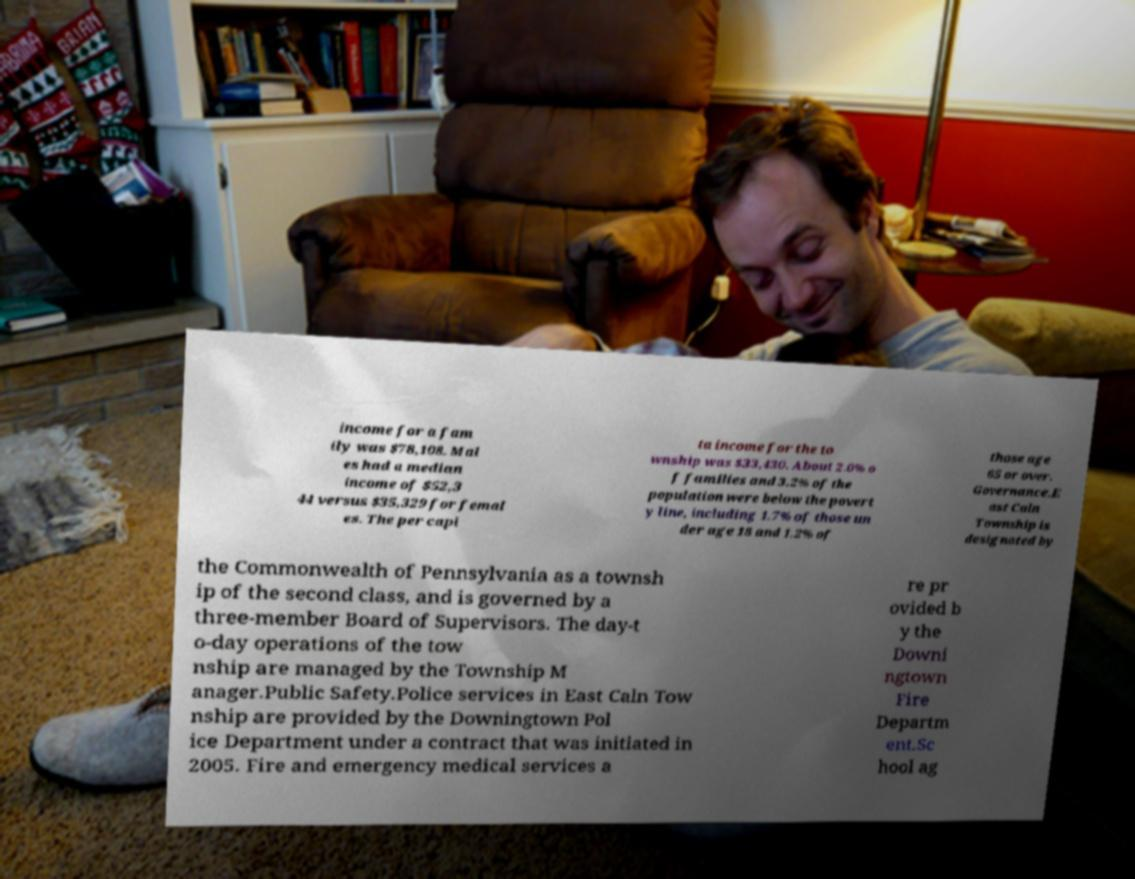There's text embedded in this image that I need extracted. Can you transcribe it verbatim? income for a fam ily was $78,108. Mal es had a median income of $52,3 44 versus $35,329 for femal es. The per capi ta income for the to wnship was $33,430. About 2.0% o f families and 3.2% of the population were below the povert y line, including 1.7% of those un der age 18 and 1.2% of those age 65 or over. Governance.E ast Caln Township is designated by the Commonwealth of Pennsylvania as a townsh ip of the second class, and is governed by a three-member Board of Supervisors. The day-t o-day operations of the tow nship are managed by the Township M anager.Public Safety.Police services in East Caln Tow nship are provided by the Downingtown Pol ice Department under a contract that was initiated in 2005. Fire and emergency medical services a re pr ovided b y the Downi ngtown Fire Departm ent.Sc hool ag 